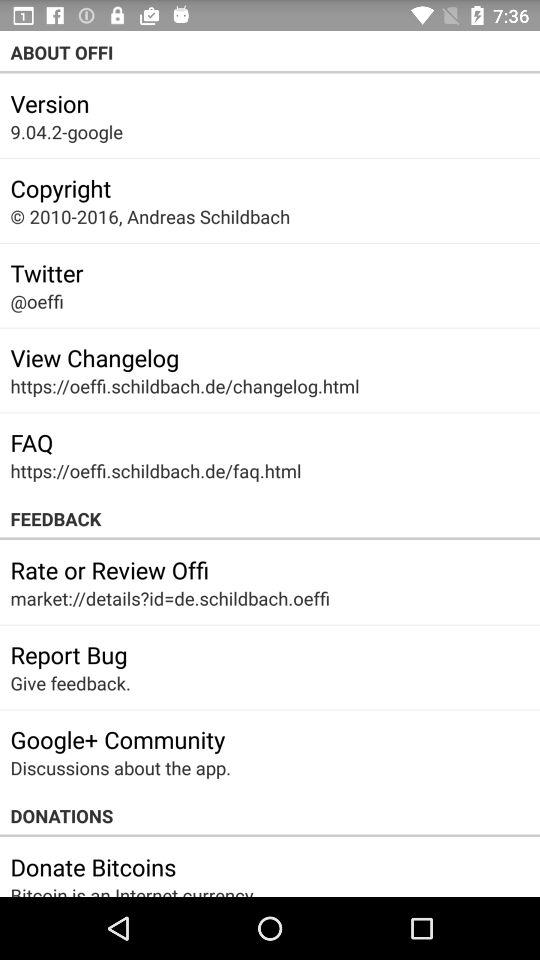What's the Twitter account? The Twitter account is "@oeffi". 